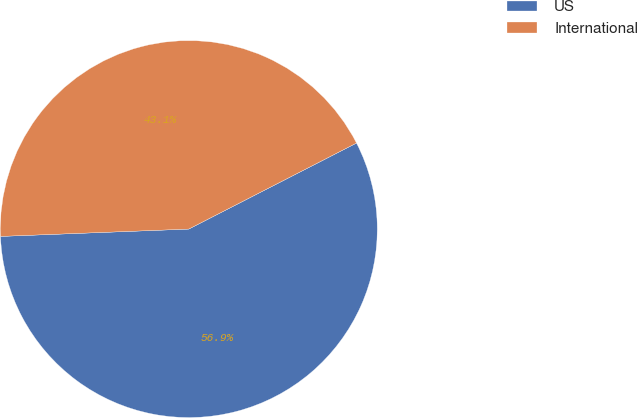Convert chart. <chart><loc_0><loc_0><loc_500><loc_500><pie_chart><fcel>US<fcel>International<nl><fcel>56.92%<fcel>43.08%<nl></chart> 